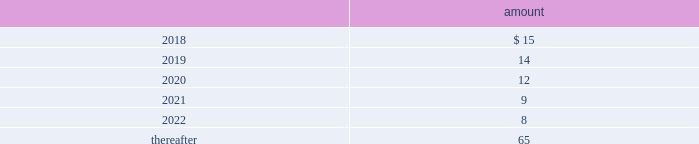Deposits 2014deposits include escrow funds and certain other deposits held in trust .
The company includes cash deposits in other current assets .
Deferred compensation obligations 2014the company 2019s deferred compensation plans allow participants to defer certain cash compensation into notional investment accounts .
The company includes such plans in other long-term liabilities .
The value of the company 2019s deferred compensation obligations is based on the market value of the participants 2019 notional investment accounts .
The notional investments are comprised primarily of mutual funds , which are based on observable market prices .
Mark-to-market derivative asset and liability 2014the company utilizes fixed-to-floating interest-rate swaps , typically designated as fair-value hedges , to achieve a targeted level of variable-rate debt as a percentage of total debt .
The company also employs derivative financial instruments in the form of variable-to-fixed interest rate swaps and forward starting interest rate swaps , classified as economic hedges and cash flow hedges , respectively , in order to fix the interest cost on existing or forecasted debt .
The company uses a calculation of future cash inflows and estimated future outflows , which are discounted , to determine the current fair value .
Additional inputs to the present value calculation include the contract terms , counterparty credit risk , interest rates and market volatility .
Other investments 2014other investments primarily represent money market funds used for active employee benefits .
The company includes other investments in other current assets .
Note 18 : leases the company has entered into operating leases involving certain facilities and equipment .
Rental expenses under operating leases were $ 29 million , $ 24 million and $ 21 million for the years ended december 31 , 2017 , 2016 and 2015 , respectively .
The operating leases for facilities will expire over the next 25 years and the operating leases for equipment will expire over the next 5 years .
Certain operating leases have renewal options ranging from one to five years .
The minimum annual future rental commitment under operating leases that have initial or remaining non-cancelable lease terms over the next 5 years and thereafter are as follows: .
The company has a series of agreements with various public entities ( the 201cpartners 201d ) to establish certain joint ventures , commonly referred to as 201cpublic-private partnerships . 201d under the public-private partnerships , the company constructed utility plant , financed by the company and the partners constructed utility plant ( connected to the company 2019s property ) , financed by the partners .
The company agreed to transfer and convey some of its real and personal property to the partners in exchange for an equal principal amount of industrial development bonds ( 201cidbs 201d ) , issued by the partners under a state industrial development bond and commercial development act .
The company leased back the total facilities , including portions funded by both the company and the partners , under leases for a period of 40 years .
The leases related to the portion of the facilities funded by the company have required payments from the company to the partners that approximate the payments required by the terms of the idbs from the partners to the company ( as the holder of the idbs ) .
As the ownership of the portion of the facilities constructed by the .
What percentage of minimum annual future rental commitment under operating leases that have initial or remaining non-cancelable lease terms is payable after 2022? 
Rationale: from here you need to than divide the amount to be paid after 2022 or 65 by the total or 123 ( 65/123 ) to get 52.8%
Computations: (((15 + 14) + (12 + 9)) + (8 + 65))
Answer: 123.0. 